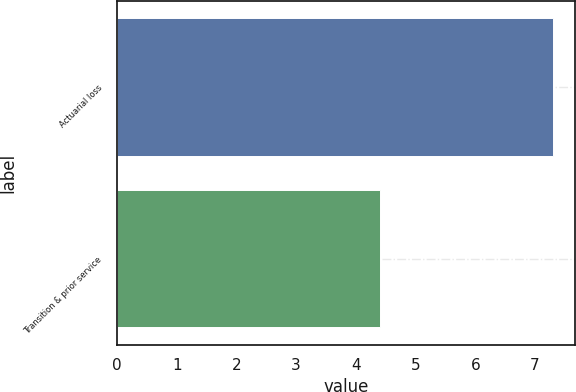Convert chart to OTSL. <chart><loc_0><loc_0><loc_500><loc_500><bar_chart><fcel>Actuarial loss<fcel>Transition & prior service<nl><fcel>7.3<fcel>4.4<nl></chart> 